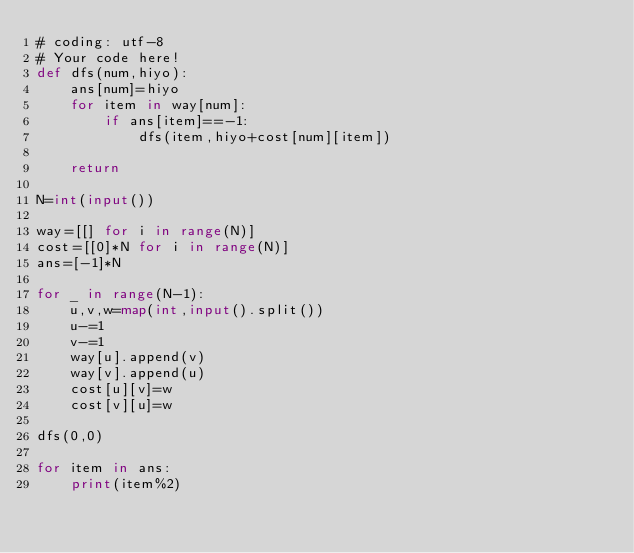<code> <loc_0><loc_0><loc_500><loc_500><_Python_># coding: utf-8
# Your code here!
def dfs(num,hiyo):
    ans[num]=hiyo
    for item in way[num]:
        if ans[item]==-1:
            dfs(item,hiyo+cost[num][item])
    
    return 

N=int(input())

way=[[] for i in range(N)]
cost=[[0]*N for i in range(N)]
ans=[-1]*N

for _ in range(N-1):
    u,v,w=map(int,input().split())
    u-=1
    v-=1
    way[u].append(v)
    way[v].append(u)
    cost[u][v]=w
    cost[v][u]=w

dfs(0,0)

for item in ans:
    print(item%2)</code> 